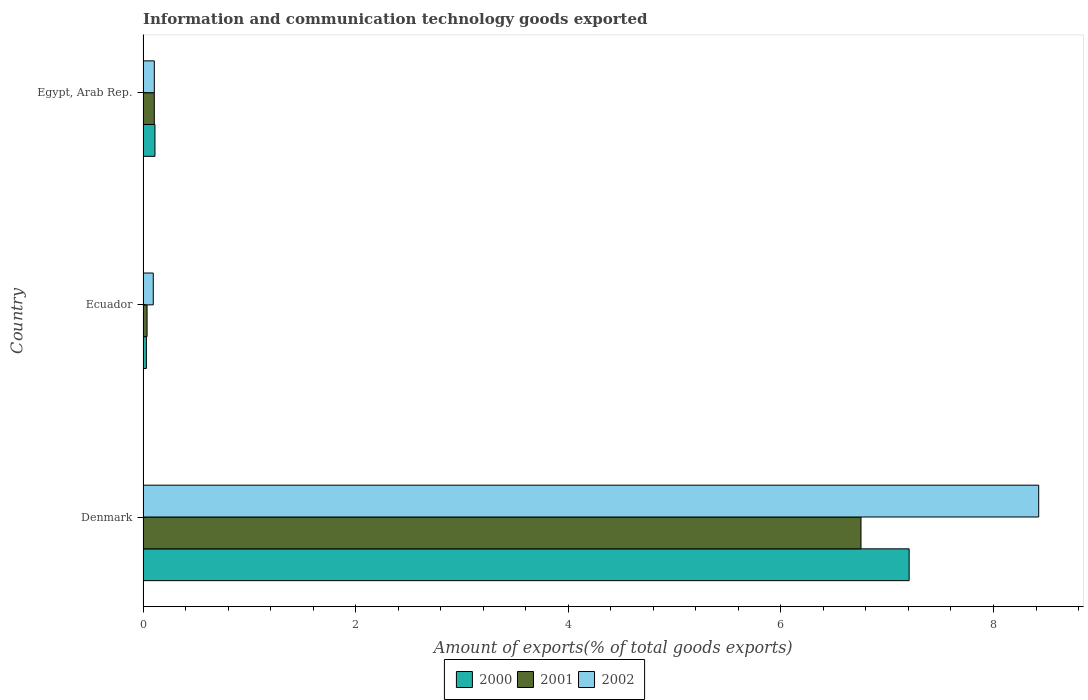How many different coloured bars are there?
Ensure brevity in your answer.  3. How many groups of bars are there?
Make the answer very short. 3. Are the number of bars per tick equal to the number of legend labels?
Give a very brief answer. Yes. How many bars are there on the 3rd tick from the bottom?
Make the answer very short. 3. What is the label of the 2nd group of bars from the top?
Your answer should be very brief. Ecuador. What is the amount of goods exported in 2002 in Denmark?
Make the answer very short. 8.43. Across all countries, what is the maximum amount of goods exported in 2001?
Your answer should be compact. 6.75. Across all countries, what is the minimum amount of goods exported in 2000?
Provide a short and direct response. 0.03. In which country was the amount of goods exported in 2002 minimum?
Ensure brevity in your answer.  Ecuador. What is the total amount of goods exported in 2001 in the graph?
Keep it short and to the point. 6.9. What is the difference between the amount of goods exported in 2002 in Ecuador and that in Egypt, Arab Rep.?
Provide a succinct answer. -0.01. What is the difference between the amount of goods exported in 2001 in Denmark and the amount of goods exported in 2002 in Ecuador?
Ensure brevity in your answer.  6.66. What is the average amount of goods exported in 2000 per country?
Provide a short and direct response. 2.45. What is the difference between the amount of goods exported in 2000 and amount of goods exported in 2002 in Egypt, Arab Rep.?
Provide a succinct answer. 0.01. What is the ratio of the amount of goods exported in 2000 in Denmark to that in Ecuador?
Make the answer very short. 230.35. Is the difference between the amount of goods exported in 2000 in Ecuador and Egypt, Arab Rep. greater than the difference between the amount of goods exported in 2002 in Ecuador and Egypt, Arab Rep.?
Offer a very short reply. No. What is the difference between the highest and the second highest amount of goods exported in 2002?
Offer a terse response. 8.32. What is the difference between the highest and the lowest amount of goods exported in 2001?
Keep it short and to the point. 6.72. In how many countries, is the amount of goods exported in 2001 greater than the average amount of goods exported in 2001 taken over all countries?
Provide a short and direct response. 1. How many bars are there?
Give a very brief answer. 9. Are all the bars in the graph horizontal?
Your answer should be very brief. Yes. How many countries are there in the graph?
Provide a short and direct response. 3. What is the difference between two consecutive major ticks on the X-axis?
Offer a terse response. 2. Where does the legend appear in the graph?
Give a very brief answer. Bottom center. How are the legend labels stacked?
Provide a succinct answer. Horizontal. What is the title of the graph?
Provide a succinct answer. Information and communication technology goods exported. What is the label or title of the X-axis?
Keep it short and to the point. Amount of exports(% of total goods exports). What is the Amount of exports(% of total goods exports) of 2000 in Denmark?
Keep it short and to the point. 7.21. What is the Amount of exports(% of total goods exports) of 2001 in Denmark?
Ensure brevity in your answer.  6.75. What is the Amount of exports(% of total goods exports) of 2002 in Denmark?
Your response must be concise. 8.43. What is the Amount of exports(% of total goods exports) of 2000 in Ecuador?
Offer a very short reply. 0.03. What is the Amount of exports(% of total goods exports) in 2001 in Ecuador?
Your response must be concise. 0.04. What is the Amount of exports(% of total goods exports) of 2002 in Ecuador?
Provide a short and direct response. 0.1. What is the Amount of exports(% of total goods exports) of 2000 in Egypt, Arab Rep.?
Your answer should be very brief. 0.11. What is the Amount of exports(% of total goods exports) in 2001 in Egypt, Arab Rep.?
Ensure brevity in your answer.  0.11. What is the Amount of exports(% of total goods exports) of 2002 in Egypt, Arab Rep.?
Provide a succinct answer. 0.11. Across all countries, what is the maximum Amount of exports(% of total goods exports) in 2000?
Your answer should be very brief. 7.21. Across all countries, what is the maximum Amount of exports(% of total goods exports) of 2001?
Provide a short and direct response. 6.75. Across all countries, what is the maximum Amount of exports(% of total goods exports) of 2002?
Your answer should be very brief. 8.43. Across all countries, what is the minimum Amount of exports(% of total goods exports) of 2000?
Offer a very short reply. 0.03. Across all countries, what is the minimum Amount of exports(% of total goods exports) in 2001?
Offer a terse response. 0.04. Across all countries, what is the minimum Amount of exports(% of total goods exports) of 2002?
Your answer should be very brief. 0.1. What is the total Amount of exports(% of total goods exports) in 2000 in the graph?
Your response must be concise. 7.35. What is the total Amount of exports(% of total goods exports) of 2001 in the graph?
Give a very brief answer. 6.9. What is the total Amount of exports(% of total goods exports) of 2002 in the graph?
Keep it short and to the point. 8.63. What is the difference between the Amount of exports(% of total goods exports) of 2000 in Denmark and that in Ecuador?
Your answer should be very brief. 7.18. What is the difference between the Amount of exports(% of total goods exports) in 2001 in Denmark and that in Ecuador?
Your response must be concise. 6.72. What is the difference between the Amount of exports(% of total goods exports) of 2002 in Denmark and that in Ecuador?
Offer a terse response. 8.33. What is the difference between the Amount of exports(% of total goods exports) of 2000 in Denmark and that in Egypt, Arab Rep.?
Offer a very short reply. 7.09. What is the difference between the Amount of exports(% of total goods exports) in 2001 in Denmark and that in Egypt, Arab Rep.?
Keep it short and to the point. 6.65. What is the difference between the Amount of exports(% of total goods exports) of 2002 in Denmark and that in Egypt, Arab Rep.?
Keep it short and to the point. 8.32. What is the difference between the Amount of exports(% of total goods exports) of 2000 in Ecuador and that in Egypt, Arab Rep.?
Your response must be concise. -0.08. What is the difference between the Amount of exports(% of total goods exports) in 2001 in Ecuador and that in Egypt, Arab Rep.?
Provide a succinct answer. -0.07. What is the difference between the Amount of exports(% of total goods exports) of 2002 in Ecuador and that in Egypt, Arab Rep.?
Offer a terse response. -0.01. What is the difference between the Amount of exports(% of total goods exports) in 2000 in Denmark and the Amount of exports(% of total goods exports) in 2001 in Ecuador?
Keep it short and to the point. 7.17. What is the difference between the Amount of exports(% of total goods exports) of 2000 in Denmark and the Amount of exports(% of total goods exports) of 2002 in Ecuador?
Provide a succinct answer. 7.11. What is the difference between the Amount of exports(% of total goods exports) in 2001 in Denmark and the Amount of exports(% of total goods exports) in 2002 in Ecuador?
Keep it short and to the point. 6.66. What is the difference between the Amount of exports(% of total goods exports) in 2000 in Denmark and the Amount of exports(% of total goods exports) in 2001 in Egypt, Arab Rep.?
Keep it short and to the point. 7.1. What is the difference between the Amount of exports(% of total goods exports) in 2000 in Denmark and the Amount of exports(% of total goods exports) in 2002 in Egypt, Arab Rep.?
Make the answer very short. 7.1. What is the difference between the Amount of exports(% of total goods exports) in 2001 in Denmark and the Amount of exports(% of total goods exports) in 2002 in Egypt, Arab Rep.?
Your answer should be very brief. 6.65. What is the difference between the Amount of exports(% of total goods exports) of 2000 in Ecuador and the Amount of exports(% of total goods exports) of 2001 in Egypt, Arab Rep.?
Make the answer very short. -0.07. What is the difference between the Amount of exports(% of total goods exports) of 2000 in Ecuador and the Amount of exports(% of total goods exports) of 2002 in Egypt, Arab Rep.?
Provide a succinct answer. -0.07. What is the difference between the Amount of exports(% of total goods exports) in 2001 in Ecuador and the Amount of exports(% of total goods exports) in 2002 in Egypt, Arab Rep.?
Provide a succinct answer. -0.07. What is the average Amount of exports(% of total goods exports) of 2000 per country?
Ensure brevity in your answer.  2.45. What is the average Amount of exports(% of total goods exports) in 2001 per country?
Give a very brief answer. 2.3. What is the average Amount of exports(% of total goods exports) in 2002 per country?
Your answer should be very brief. 2.88. What is the difference between the Amount of exports(% of total goods exports) of 2000 and Amount of exports(% of total goods exports) of 2001 in Denmark?
Offer a very short reply. 0.45. What is the difference between the Amount of exports(% of total goods exports) in 2000 and Amount of exports(% of total goods exports) in 2002 in Denmark?
Ensure brevity in your answer.  -1.22. What is the difference between the Amount of exports(% of total goods exports) of 2001 and Amount of exports(% of total goods exports) of 2002 in Denmark?
Your response must be concise. -1.67. What is the difference between the Amount of exports(% of total goods exports) in 2000 and Amount of exports(% of total goods exports) in 2001 in Ecuador?
Your response must be concise. -0.01. What is the difference between the Amount of exports(% of total goods exports) of 2000 and Amount of exports(% of total goods exports) of 2002 in Ecuador?
Offer a very short reply. -0.06. What is the difference between the Amount of exports(% of total goods exports) of 2001 and Amount of exports(% of total goods exports) of 2002 in Ecuador?
Your response must be concise. -0.06. What is the difference between the Amount of exports(% of total goods exports) of 2000 and Amount of exports(% of total goods exports) of 2001 in Egypt, Arab Rep.?
Ensure brevity in your answer.  0.01. What is the difference between the Amount of exports(% of total goods exports) of 2000 and Amount of exports(% of total goods exports) of 2002 in Egypt, Arab Rep.?
Your answer should be very brief. 0.01. What is the difference between the Amount of exports(% of total goods exports) in 2001 and Amount of exports(% of total goods exports) in 2002 in Egypt, Arab Rep.?
Your answer should be very brief. -0. What is the ratio of the Amount of exports(% of total goods exports) of 2000 in Denmark to that in Ecuador?
Your answer should be very brief. 230.35. What is the ratio of the Amount of exports(% of total goods exports) in 2001 in Denmark to that in Ecuador?
Your answer should be compact. 179.8. What is the ratio of the Amount of exports(% of total goods exports) in 2002 in Denmark to that in Ecuador?
Your answer should be compact. 87.73. What is the ratio of the Amount of exports(% of total goods exports) of 2000 in Denmark to that in Egypt, Arab Rep.?
Offer a very short reply. 64.33. What is the ratio of the Amount of exports(% of total goods exports) in 2001 in Denmark to that in Egypt, Arab Rep.?
Offer a terse response. 63.88. What is the ratio of the Amount of exports(% of total goods exports) in 2002 in Denmark to that in Egypt, Arab Rep.?
Provide a short and direct response. 79.52. What is the ratio of the Amount of exports(% of total goods exports) in 2000 in Ecuador to that in Egypt, Arab Rep.?
Your answer should be very brief. 0.28. What is the ratio of the Amount of exports(% of total goods exports) of 2001 in Ecuador to that in Egypt, Arab Rep.?
Your answer should be very brief. 0.36. What is the ratio of the Amount of exports(% of total goods exports) in 2002 in Ecuador to that in Egypt, Arab Rep.?
Offer a very short reply. 0.91. What is the difference between the highest and the second highest Amount of exports(% of total goods exports) of 2000?
Your response must be concise. 7.09. What is the difference between the highest and the second highest Amount of exports(% of total goods exports) in 2001?
Provide a succinct answer. 6.65. What is the difference between the highest and the second highest Amount of exports(% of total goods exports) of 2002?
Offer a very short reply. 8.32. What is the difference between the highest and the lowest Amount of exports(% of total goods exports) in 2000?
Ensure brevity in your answer.  7.18. What is the difference between the highest and the lowest Amount of exports(% of total goods exports) of 2001?
Provide a succinct answer. 6.72. What is the difference between the highest and the lowest Amount of exports(% of total goods exports) of 2002?
Ensure brevity in your answer.  8.33. 